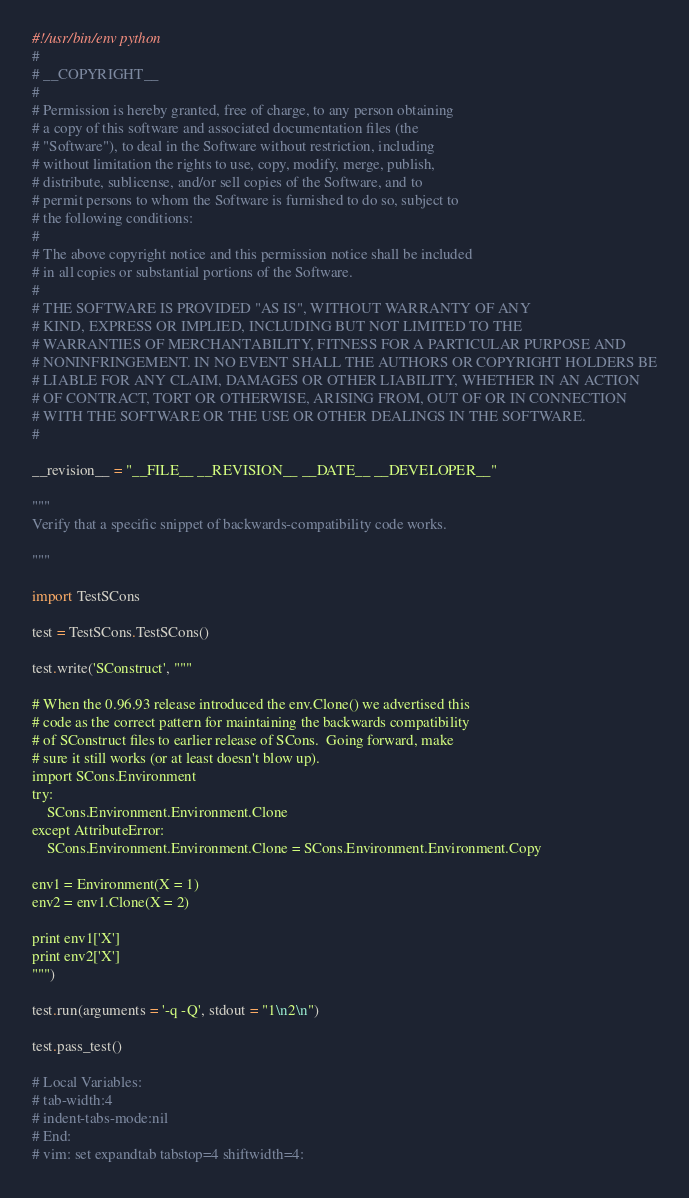Convert code to text. <code><loc_0><loc_0><loc_500><loc_500><_Python_>#!/usr/bin/env python
#
# __COPYRIGHT__
#
# Permission is hereby granted, free of charge, to any person obtaining
# a copy of this software and associated documentation files (the
# "Software"), to deal in the Software without restriction, including
# without limitation the rights to use, copy, modify, merge, publish,
# distribute, sublicense, and/or sell copies of the Software, and to
# permit persons to whom the Software is furnished to do so, subject to
# the following conditions:
#
# The above copyright notice and this permission notice shall be included
# in all copies or substantial portions of the Software.
#
# THE SOFTWARE IS PROVIDED "AS IS", WITHOUT WARRANTY OF ANY
# KIND, EXPRESS OR IMPLIED, INCLUDING BUT NOT LIMITED TO THE
# WARRANTIES OF MERCHANTABILITY, FITNESS FOR A PARTICULAR PURPOSE AND
# NONINFRINGEMENT. IN NO EVENT SHALL THE AUTHORS OR COPYRIGHT HOLDERS BE
# LIABLE FOR ANY CLAIM, DAMAGES OR OTHER LIABILITY, WHETHER IN AN ACTION
# OF CONTRACT, TORT OR OTHERWISE, ARISING FROM, OUT OF OR IN CONNECTION
# WITH THE SOFTWARE OR THE USE OR OTHER DEALINGS IN THE SOFTWARE.
#

__revision__ = "__FILE__ __REVISION__ __DATE__ __DEVELOPER__"

"""
Verify that a specific snippet of backwards-compatibility code works.

"""

import TestSCons

test = TestSCons.TestSCons()

test.write('SConstruct', """

# When the 0.96.93 release introduced the env.Clone() we advertised this
# code as the correct pattern for maintaining the backwards compatibility
# of SConstruct files to earlier release of SCons.  Going forward, make
# sure it still works (or at least doesn't blow up).
import SCons.Environment
try:
    SCons.Environment.Environment.Clone
except AttributeError:
    SCons.Environment.Environment.Clone = SCons.Environment.Environment.Copy

env1 = Environment(X = 1)
env2 = env1.Clone(X = 2)

print env1['X']
print env2['X']
""")

test.run(arguments = '-q -Q', stdout = "1\n2\n")

test.pass_test()

# Local Variables:
# tab-width:4
# indent-tabs-mode:nil
# End:
# vim: set expandtab tabstop=4 shiftwidth=4:
</code> 